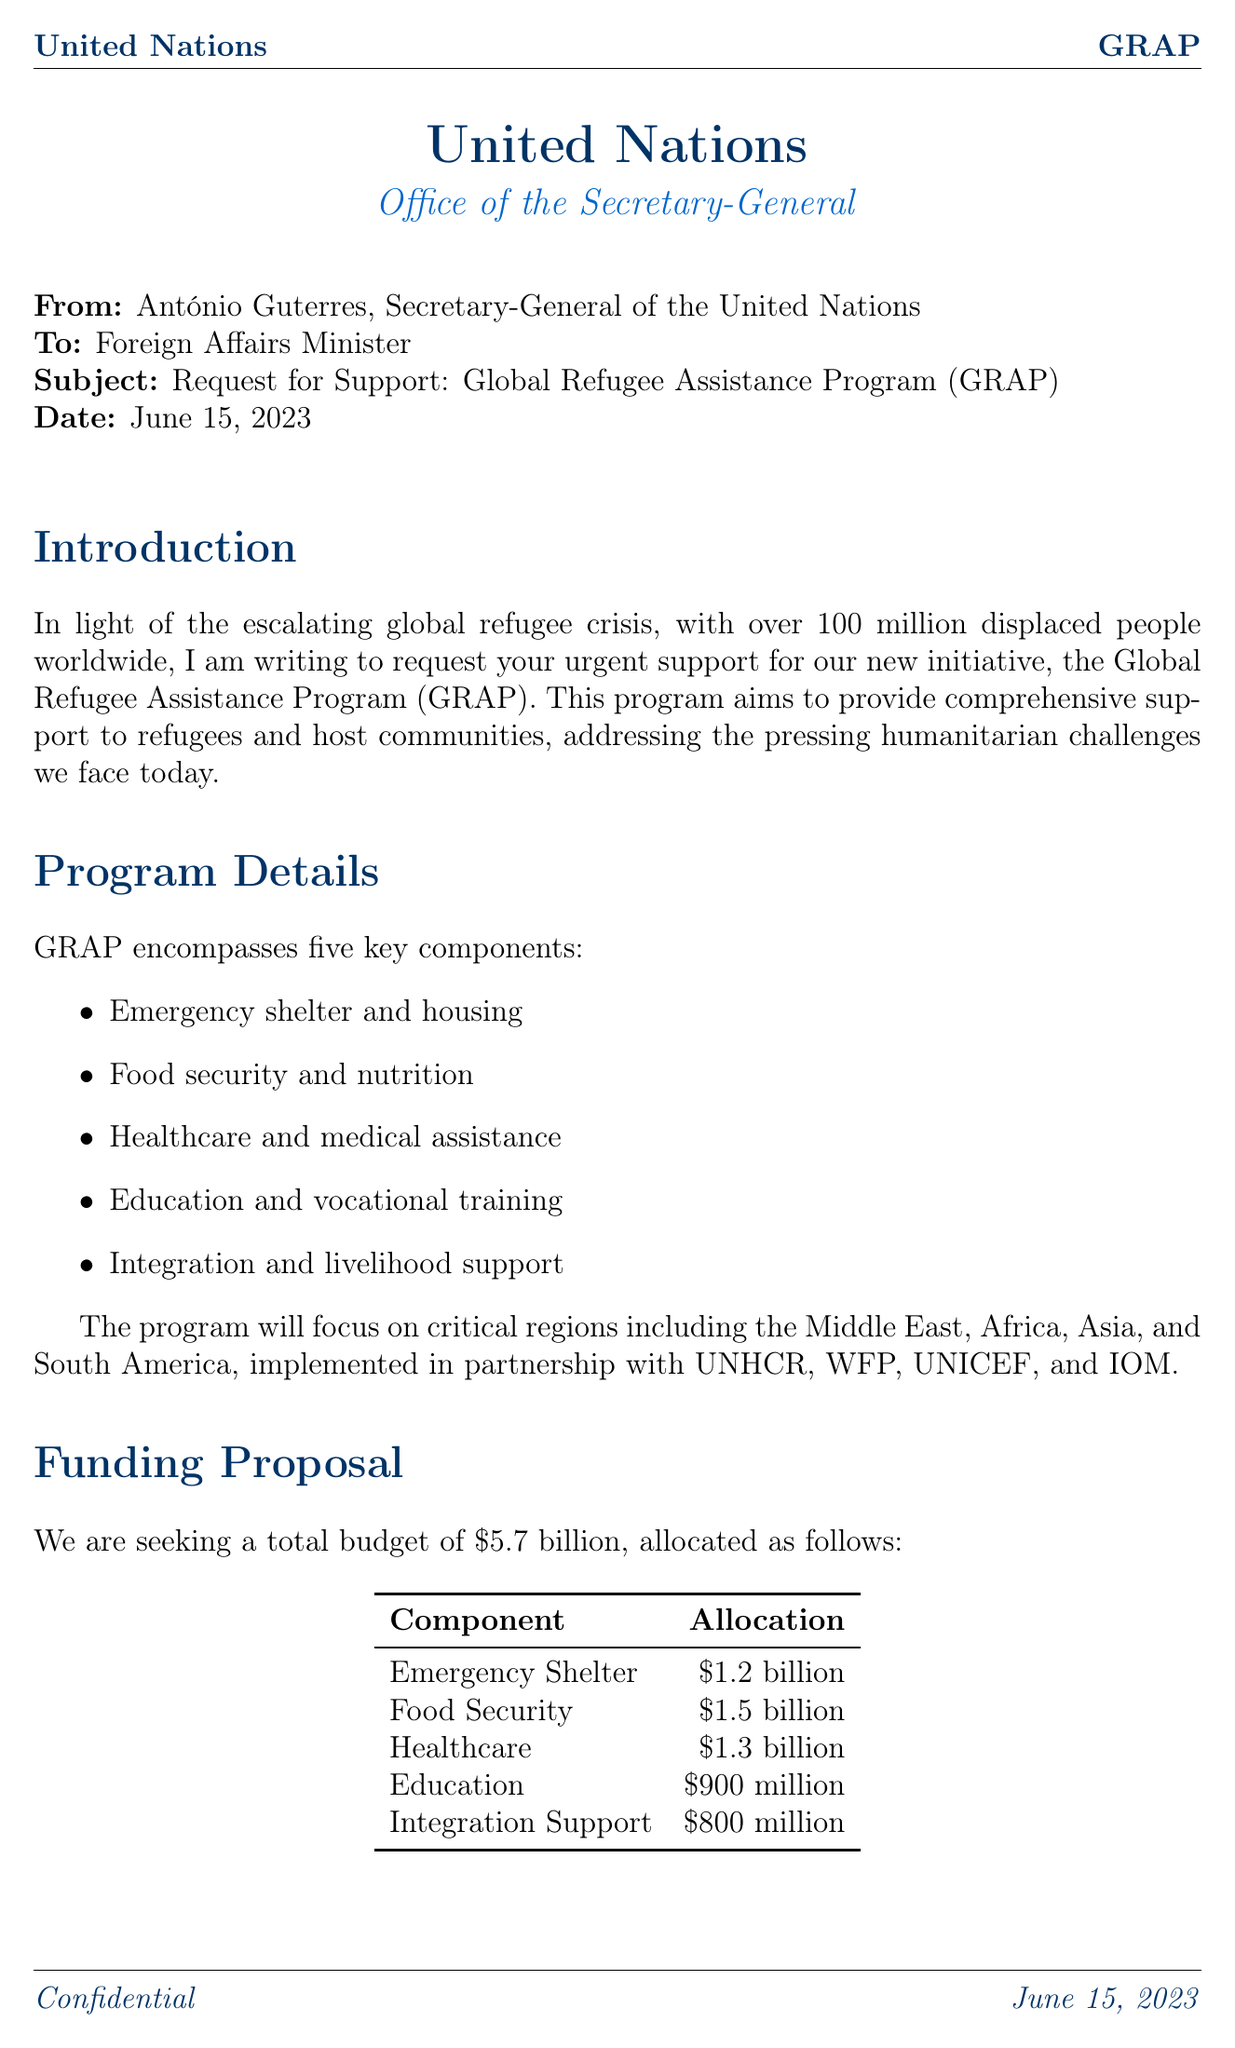what is the total budget for the Global Refugee Assistance Program (GRAP)? The total budget is specified in the funding proposal section of the letter.
Answer: $5.7 billion who is the Secretary-General of the United Nations? The letter is addressed from António Guterres, who is the Secretary-General.
Answer: António Guterres what are the target regions for the GRAP? The document lists specific regions where the program will focus its efforts.
Answer: Middle East, Africa, Asia, South America how many refugees is the program expected to provide immediate relief for? This detail is provided in the expected outcomes section regarding immediate relief efforts.
Answer: 5 million what is the primary goal of the Global Refugee Assistance Program? The main objective of the program is stated clearly in the introduction of the letter.
Answer: Provide comprehensive support to refugees and host communities which organization is responsible for independent audits of the program? The accountability section of the letter mentions the organization conducting audits.
Answer: PricewaterhouseCoopers what is one of the key components of the GRAP? The program details section lists several key components of the program.
Answer: Emergency shelter and housing what type of funding mechanism is mentioned in the proposal? The funding proposal includes various mechanisms for securing the necessary funds.
Answer: Multi-donor trust fund 